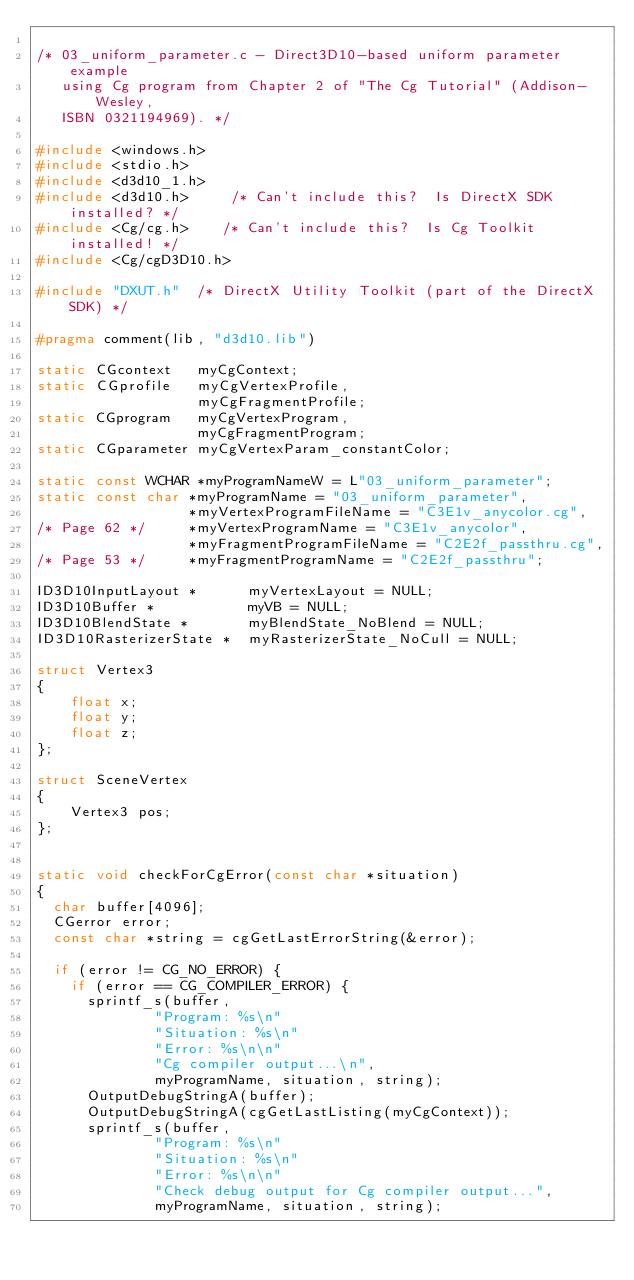<code> <loc_0><loc_0><loc_500><loc_500><_C++_>
/* 03_uniform_parameter.c - Direct3D10-based uniform parameter example
   using Cg program from Chapter 2 of "The Cg Tutorial" (Addison-Wesley,
   ISBN 0321194969). */

#include <windows.h>
#include <stdio.h>
#include <d3d10_1.h>
#include <d3d10.h>     /* Can't include this?  Is DirectX SDK installed? */
#include <Cg/cg.h>    /* Can't include this?  Is Cg Toolkit installed! */
#include <Cg/cgD3D10.h>

#include "DXUT.h"  /* DirectX Utility Toolkit (part of the DirectX SDK) */

#pragma comment(lib, "d3d10.lib")

static CGcontext   myCgContext;
static CGprofile   myCgVertexProfile,
                   myCgFragmentProfile;
static CGprogram   myCgVertexProgram,
                   myCgFragmentProgram;
static CGparameter myCgVertexParam_constantColor;

static const WCHAR *myProgramNameW = L"03_uniform_parameter";
static const char *myProgramName = "03_uniform_parameter",
                  *myVertexProgramFileName = "C3E1v_anycolor.cg",
/* Page 62 */     *myVertexProgramName = "C3E1v_anycolor",
                  *myFragmentProgramFileName = "C2E2f_passthru.cg",
/* Page 53 */     *myFragmentProgramName = "C2E2f_passthru";

ID3D10InputLayout *      myVertexLayout = NULL;
ID3D10Buffer *           myVB = NULL;
ID3D10BlendState *       myBlendState_NoBlend = NULL;
ID3D10RasterizerState *	 myRasterizerState_NoCull = NULL;

struct Vertex3
{
    float x;
    float y;
    float z;
};

struct SceneVertex
{
    Vertex3 pos;
};


static void checkForCgError(const char *situation)
{
  char buffer[4096];
  CGerror error;
  const char *string = cgGetLastErrorString(&error);
  
  if (error != CG_NO_ERROR) {
    if (error == CG_COMPILER_ERROR) {
      sprintf_s(buffer,
              "Program: %s\n"
              "Situation: %s\n"
              "Error: %s\n\n"
              "Cg compiler output...\n",
              myProgramName, situation, string);
      OutputDebugStringA(buffer);
      OutputDebugStringA(cgGetLastListing(myCgContext));
      sprintf_s(buffer,
              "Program: %s\n"
              "Situation: %s\n"
              "Error: %s\n\n"
              "Check debug output for Cg compiler output...",
              myProgramName, situation, string);</code> 